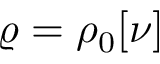<formula> <loc_0><loc_0><loc_500><loc_500>\varrho = \rho _ { 0 } [ \nu ]</formula> 